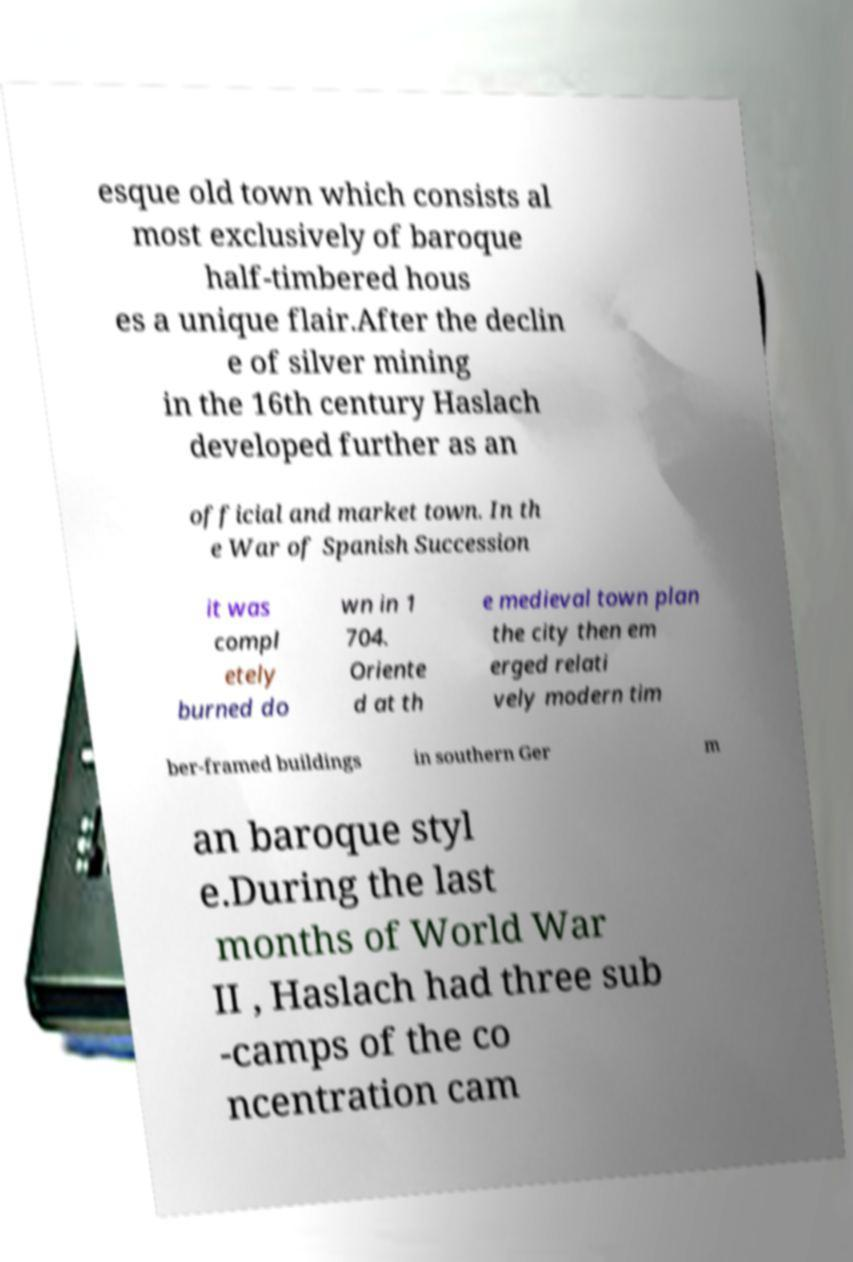What messages or text are displayed in this image? I need them in a readable, typed format. esque old town which consists al most exclusively of baroque half-timbered hous es a unique flair.After the declin e of silver mining in the 16th century Haslach developed further as an official and market town. In th e War of Spanish Succession it was compl etely burned do wn in 1 704. Oriente d at th e medieval town plan the city then em erged relati vely modern tim ber-framed buildings in southern Ger m an baroque styl e.During the last months of World War II , Haslach had three sub -camps of the co ncentration cam 